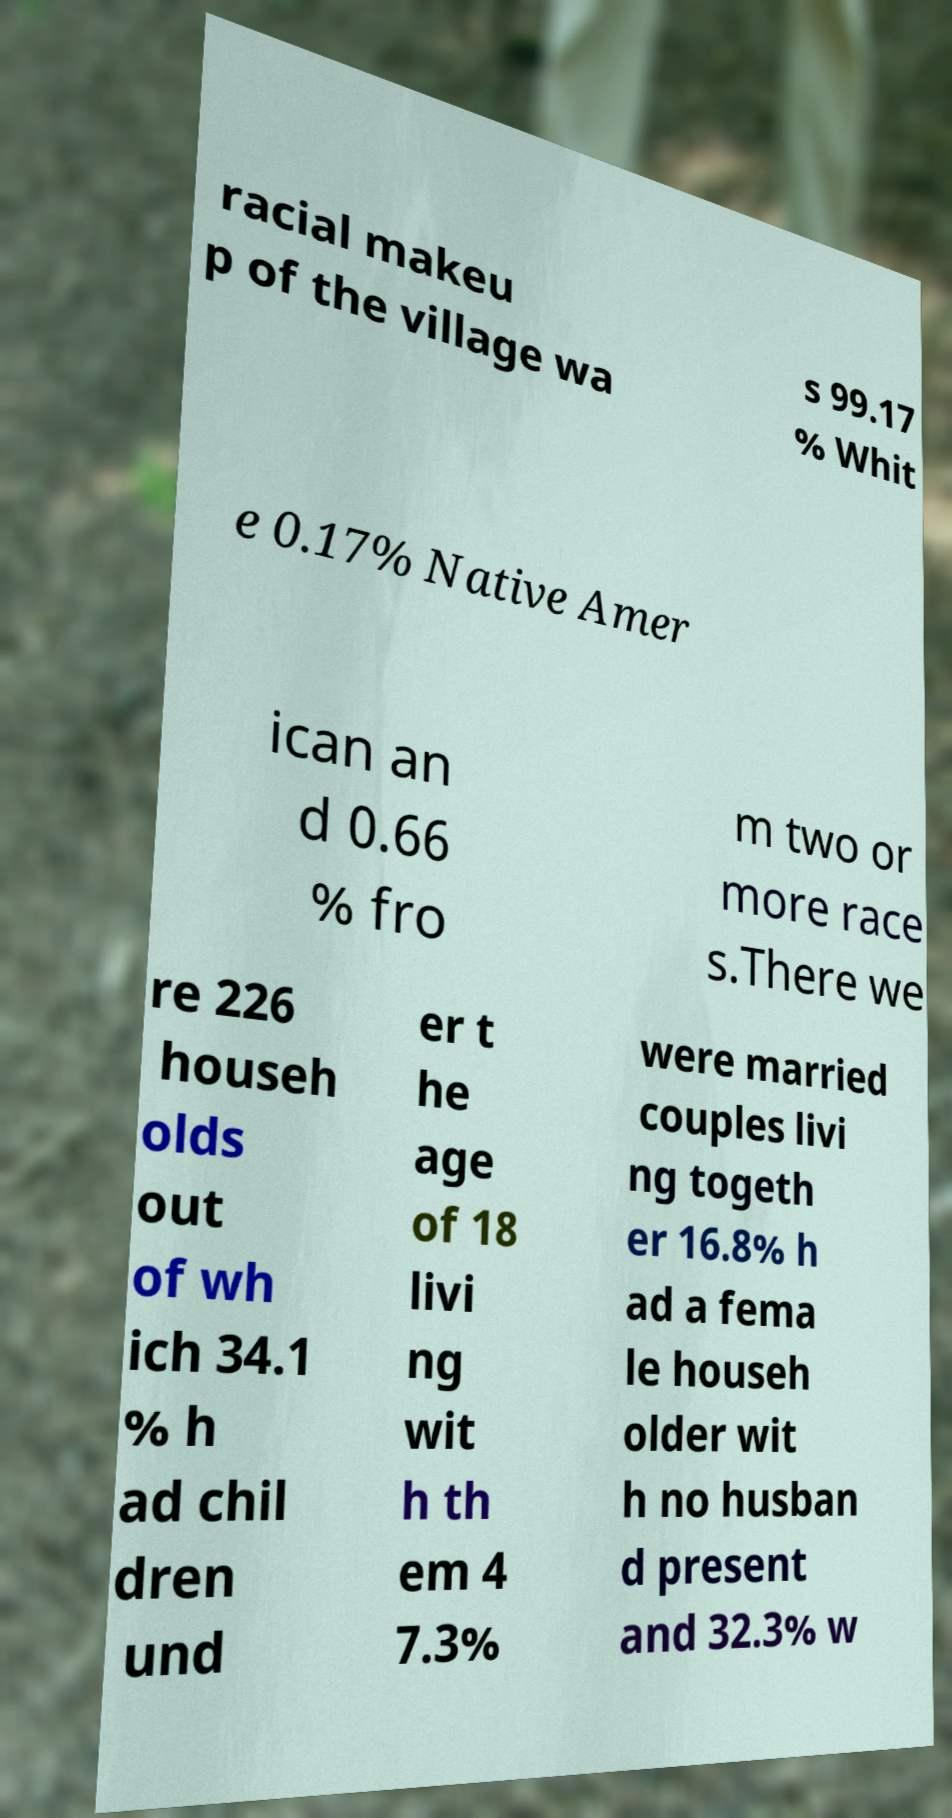Could you assist in decoding the text presented in this image and type it out clearly? racial makeu p of the village wa s 99.17 % Whit e 0.17% Native Amer ican an d 0.66 % fro m two or more race s.There we re 226 househ olds out of wh ich 34.1 % h ad chil dren und er t he age of 18 livi ng wit h th em 4 7.3% were married couples livi ng togeth er 16.8% h ad a fema le househ older wit h no husban d present and 32.3% w 